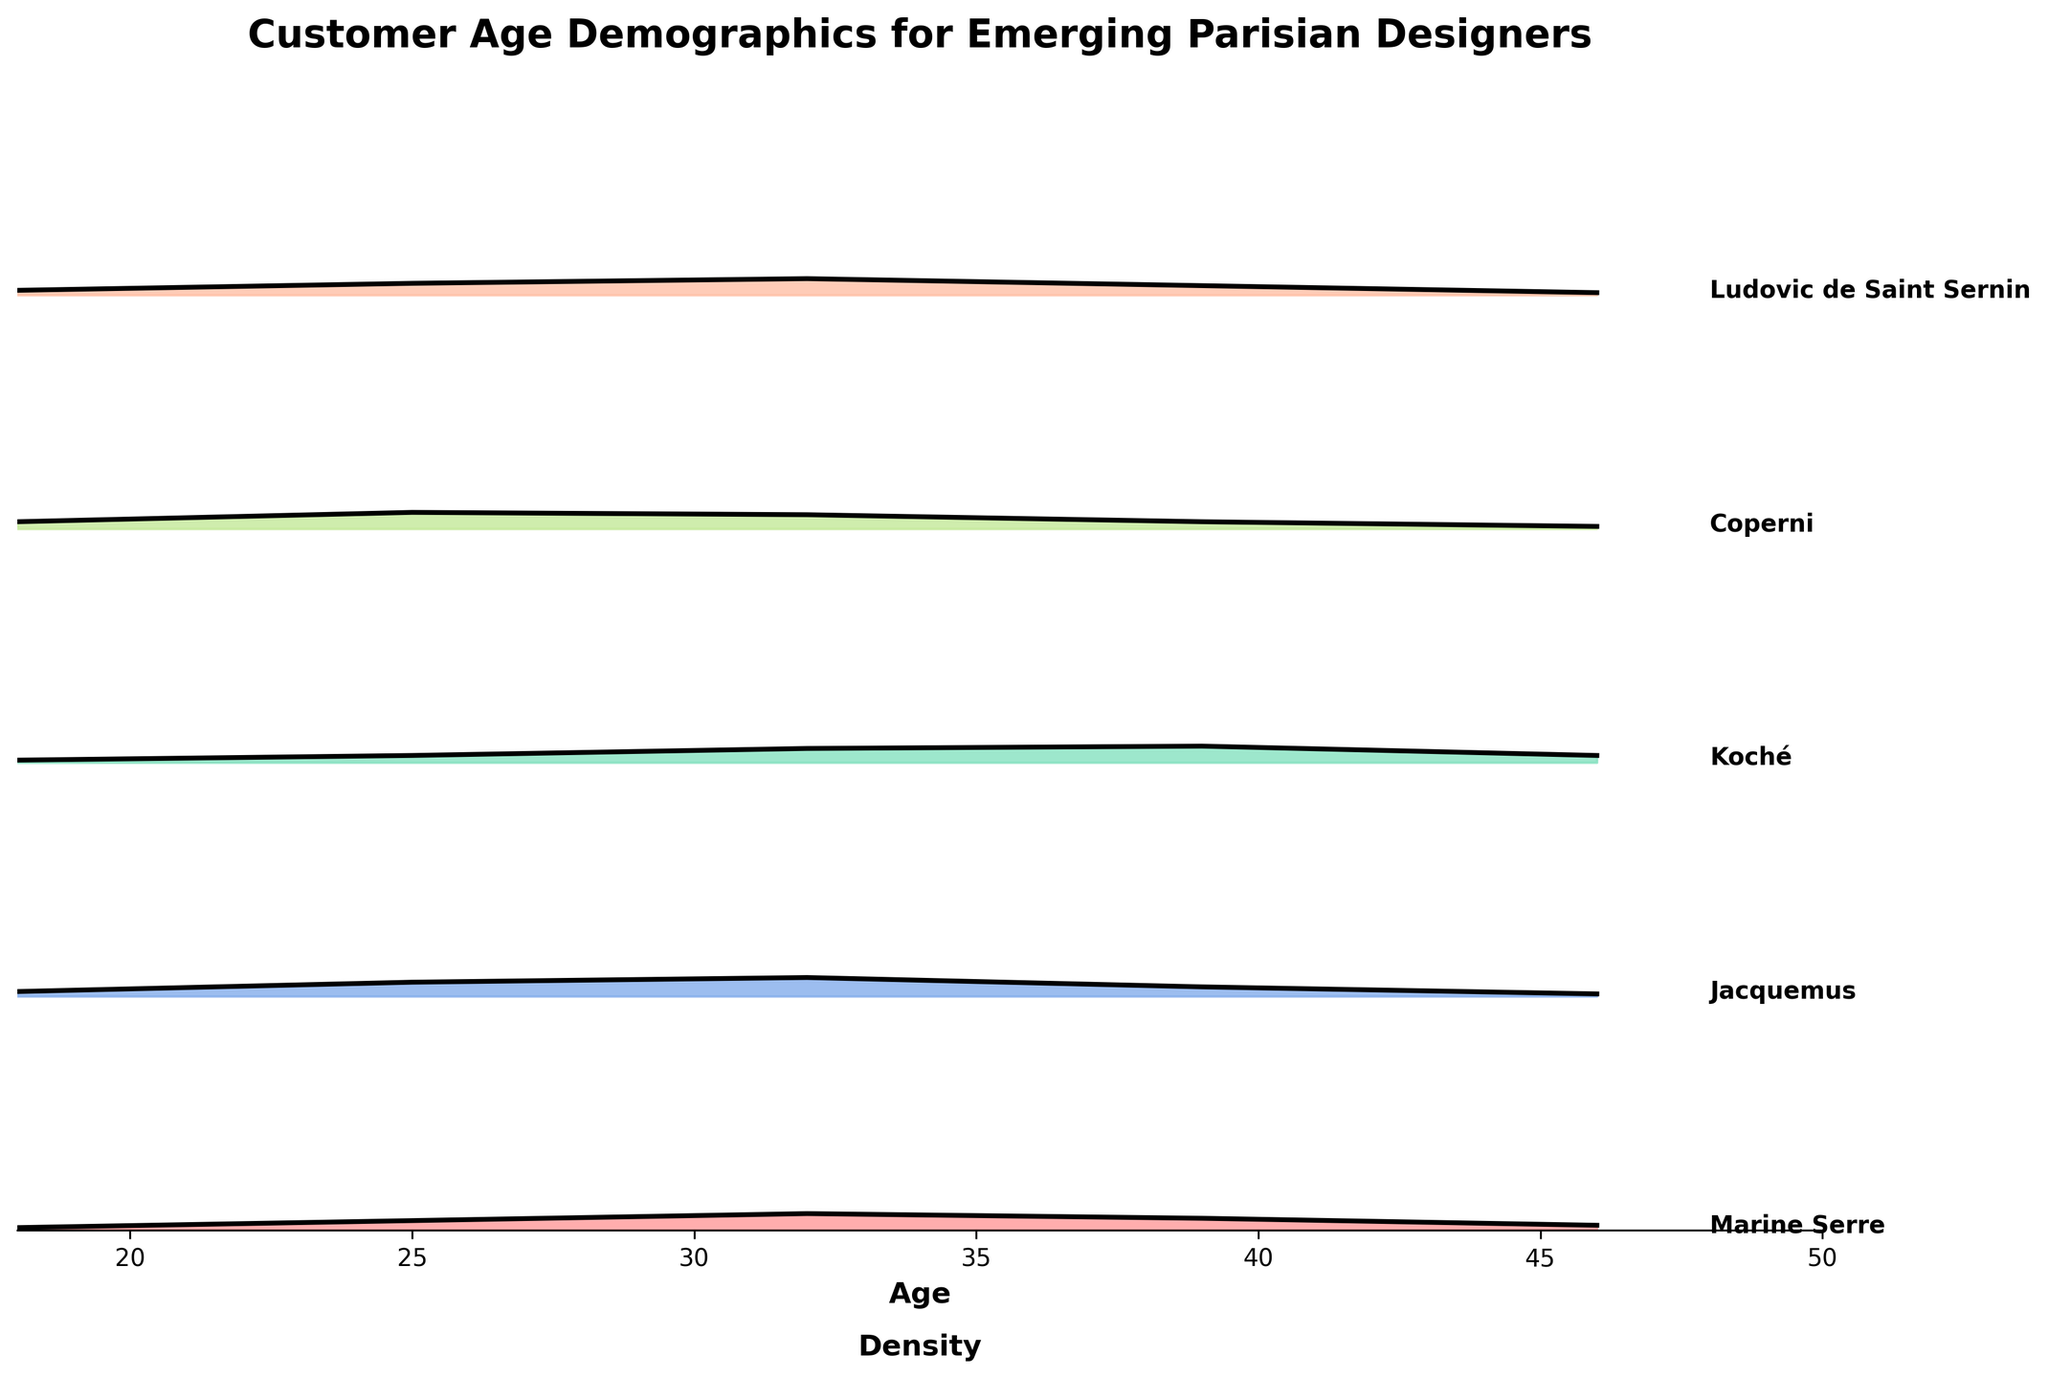What does the title of the plot say? The title is located at the top of the plot and provides an overview of the subject matter being displayed. Here, it states "Customer Age Demographics for Emerging Parisian Designers."
Answer: Customer Age Demographics for Emerging Parisian Designers Which age group has the highest density for Jacquemus? To find this, locate the Jacquemus layer in the plot, then identify the age with the highest density value along the density curve.
Answer: 32 How many designer labels are showcased in the plot? Count the number of unique designers listed along the y-axis or at the right side of the plot. There are five distinct labels: Marine Serre, Jacquemus, Koché, Coperni, and Ludovic de Saint Sernin.
Answer: 5 Between the ages of 25 and 32, which designer sees the most significant increase in density? Compare the density values at ages 25 and 32 for each designer. Identify the designer whose density increases the most between these two age groups.
Answer: Coperni Which designer has the broadest age distribution peak? Look for the designer whose density curve spans the widest range of ages. This occurs where the curve covers a broader base on the x-axis.
Answer: Marine Serre What is the density for Marine Serre at age 39? Locate the age 39 on the x-axis, then follow the density curve for Marine Serre at that age.
Answer: 0.05 Does any designer have a density of 0.03 at any age? If so, which designer(s) and age(s)? Check the y-values for all designers at various ages to see if any density equals 0.03. Koché at age 25 and 46, and Coperni at age 39 have a density of 0.03.
Answer: Koché at 25 and 46, Coperni at 39 Which designer attracts the youngest customer base? Identify which designer's density peak (or highest density) is at the lowest age. This suggests that designer's primary customer base includes younger consumers.
Answer: Jacquemus Which designer shows a steady decline in density as age increases from 18 to 46? Look for a designer whose density values consistently decrease from age 18 to age 46. This pattern is shown by Jacquemus.
Answer: Jacquemus 